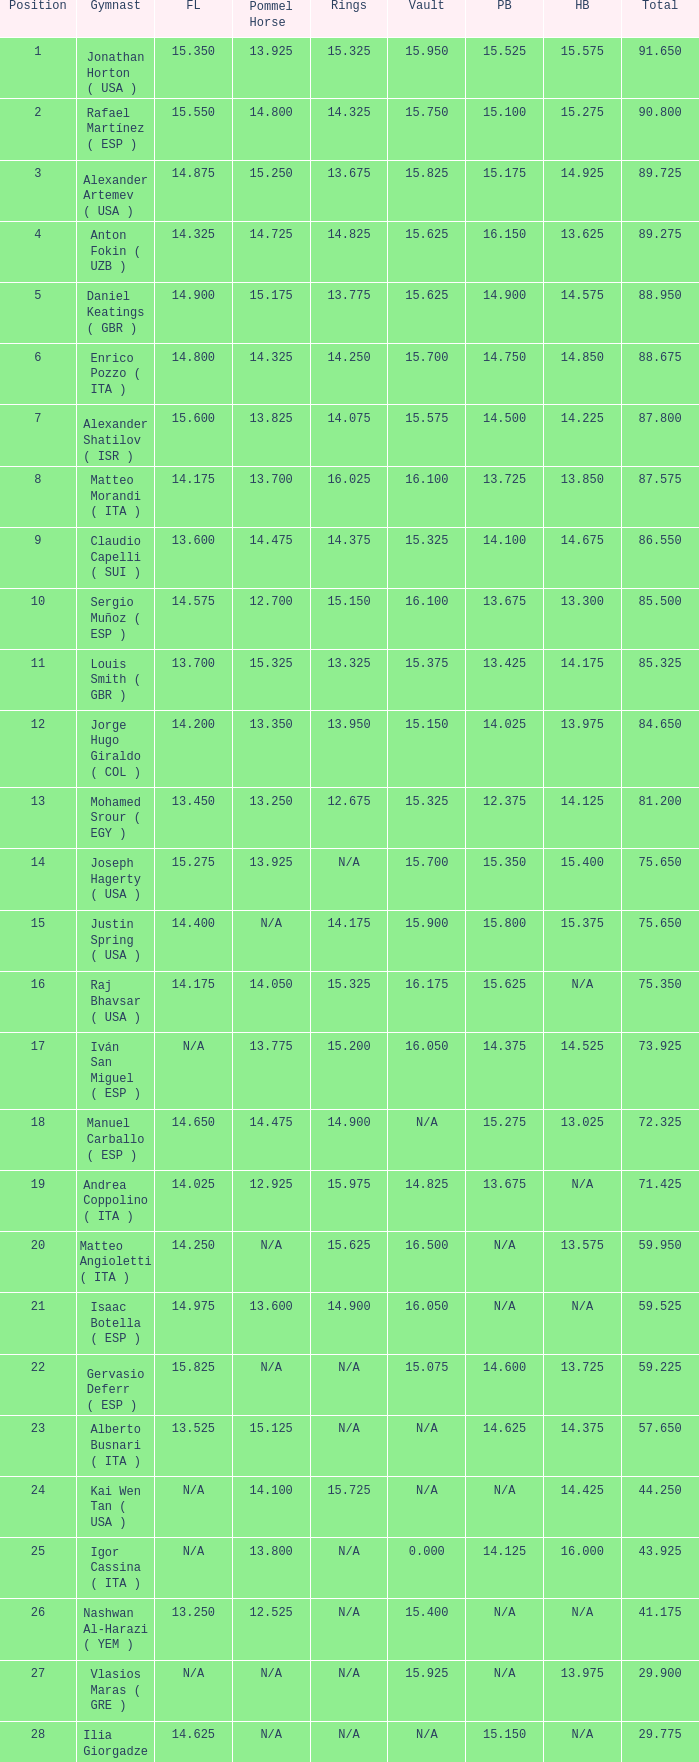Would you be able to parse every entry in this table? {'header': ['Position', 'Gymnast', 'FL', 'Pommel Horse', 'Rings', 'Vault', 'PB', 'HB', 'Total'], 'rows': [['1', 'Jonathan Horton ( USA )', '15.350', '13.925', '15.325', '15.950', '15.525', '15.575', '91.650'], ['2', 'Rafael Martínez ( ESP )', '15.550', '14.800', '14.325', '15.750', '15.100', '15.275', '90.800'], ['3', 'Alexander Artemev ( USA )', '14.875', '15.250', '13.675', '15.825', '15.175', '14.925', '89.725'], ['4', 'Anton Fokin ( UZB )', '14.325', '14.725', '14.825', '15.625', '16.150', '13.625', '89.275'], ['5', 'Daniel Keatings ( GBR )', '14.900', '15.175', '13.775', '15.625', '14.900', '14.575', '88.950'], ['6', 'Enrico Pozzo ( ITA )', '14.800', '14.325', '14.250', '15.700', '14.750', '14.850', '88.675'], ['7', 'Alexander Shatilov ( ISR )', '15.600', '13.825', '14.075', '15.575', '14.500', '14.225', '87.800'], ['8', 'Matteo Morandi ( ITA )', '14.175', '13.700', '16.025', '16.100', '13.725', '13.850', '87.575'], ['9', 'Claudio Capelli ( SUI )', '13.600', '14.475', '14.375', '15.325', '14.100', '14.675', '86.550'], ['10', 'Sergio Muñoz ( ESP )', '14.575', '12.700', '15.150', '16.100', '13.675', '13.300', '85.500'], ['11', 'Louis Smith ( GBR )', '13.700', '15.325', '13.325', '15.375', '13.425', '14.175', '85.325'], ['12', 'Jorge Hugo Giraldo ( COL )', '14.200', '13.350', '13.950', '15.150', '14.025', '13.975', '84.650'], ['13', 'Mohamed Srour ( EGY )', '13.450', '13.250', '12.675', '15.325', '12.375', '14.125', '81.200'], ['14', 'Joseph Hagerty ( USA )', '15.275', '13.925', 'N/A', '15.700', '15.350', '15.400', '75.650'], ['15', 'Justin Spring ( USA )', '14.400', 'N/A', '14.175', '15.900', '15.800', '15.375', '75.650'], ['16', 'Raj Bhavsar ( USA )', '14.175', '14.050', '15.325', '16.175', '15.625', 'N/A', '75.350'], ['17', 'Iván San Miguel ( ESP )', 'N/A', '13.775', '15.200', '16.050', '14.375', '14.525', '73.925'], ['18', 'Manuel Carballo ( ESP )', '14.650', '14.475', '14.900', 'N/A', '15.275', '13.025', '72.325'], ['19', 'Andrea Coppolino ( ITA )', '14.025', '12.925', '15.975', '14.825', '13.675', 'N/A', '71.425'], ['20', 'Matteo Angioletti ( ITA )', '14.250', 'N/A', '15.625', '16.500', 'N/A', '13.575', '59.950'], ['21', 'Isaac Botella ( ESP )', '14.975', '13.600', '14.900', '16.050', 'N/A', 'N/A', '59.525'], ['22', 'Gervasio Deferr ( ESP )', '15.825', 'N/A', 'N/A', '15.075', '14.600', '13.725', '59.225'], ['23', 'Alberto Busnari ( ITA )', '13.525', '15.125', 'N/A', 'N/A', '14.625', '14.375', '57.650'], ['24', 'Kai Wen Tan ( USA )', 'N/A', '14.100', '15.725', 'N/A', 'N/A', '14.425', '44.250'], ['25', 'Igor Cassina ( ITA )', 'N/A', '13.800', 'N/A', '0.000', '14.125', '16.000', '43.925'], ['26', 'Nashwan Al-Harazi ( YEM )', '13.250', '12.525', 'N/A', '15.400', 'N/A', 'N/A', '41.175'], ['27', 'Vlasios Maras ( GRE )', 'N/A', 'N/A', 'N/A', '15.925', 'N/A', '13.975', '29.900'], ['28', 'Ilia Giorgadze ( GEO )', '14.625', 'N/A', 'N/A', 'N/A', '15.150', 'N/A', '29.775'], ['29', 'Christoph Schärer ( SUI )', 'N/A', '13.150', 'N/A', 'N/A', 'N/A', '15.350', '28.500'], ['30', 'Leszek Blanik ( POL )', 'N/A', 'N/A', 'N/A', '16.700', 'N/A', 'N/A', '16.700']]} If the parallel bars is 16.150, who is the gymnast? Anton Fokin ( UZB ). 